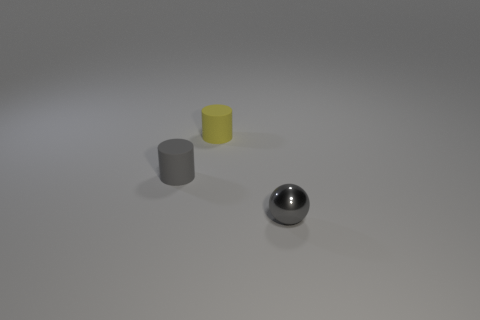Add 1 large brown objects. How many objects exist? 4 Subtract all balls. How many objects are left? 2 Subtract 0 purple spheres. How many objects are left? 3 Subtract all red metal objects. Subtract all tiny yellow rubber objects. How many objects are left? 2 Add 2 small gray metallic spheres. How many small gray metallic spheres are left? 3 Add 3 rubber objects. How many rubber objects exist? 5 